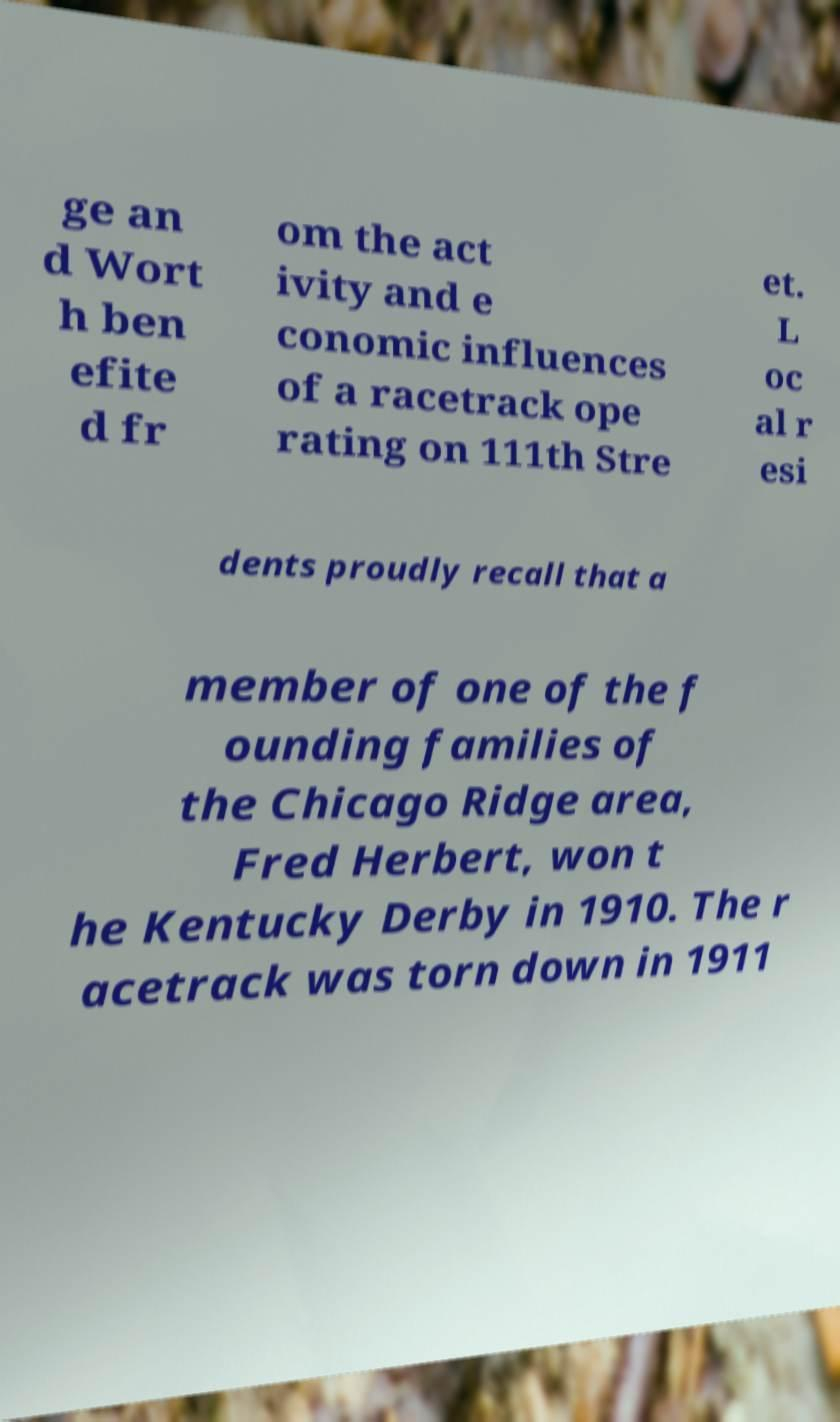Please read and relay the text visible in this image. What does it say? ge an d Wort h ben efite d fr om the act ivity and e conomic influences of a racetrack ope rating on 111th Stre et. L oc al r esi dents proudly recall that a member of one of the f ounding families of the Chicago Ridge area, Fred Herbert, won t he Kentucky Derby in 1910. The r acetrack was torn down in 1911 